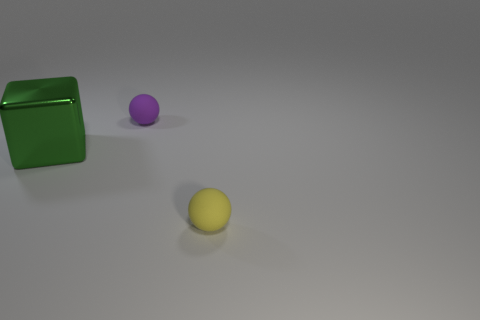Do the purple thing to the right of the green object and the big green object have the same size?
Ensure brevity in your answer.  No. There is a thing to the left of the purple ball; what material is it?
Your response must be concise. Metal. There is another small rubber object that is the same shape as the purple thing; what color is it?
Give a very brief answer. Yellow. Does the purple sphere have the same size as the object to the left of the purple rubber thing?
Make the answer very short. No. What number of objects are purple things or things in front of the large cube?
Your answer should be very brief. 2. Is the sphere that is behind the large thing made of the same material as the large green thing?
Your answer should be compact. No. The rubber ball that is the same size as the purple rubber object is what color?
Your answer should be compact. Yellow. Is there a small yellow rubber thing of the same shape as the purple object?
Provide a short and direct response. Yes. There is a rubber object behind the tiny matte ball that is in front of the big green thing on the left side of the purple matte thing; what is its color?
Ensure brevity in your answer.  Purple. What number of shiny objects are either big blocks or small yellow balls?
Provide a succinct answer. 1. 